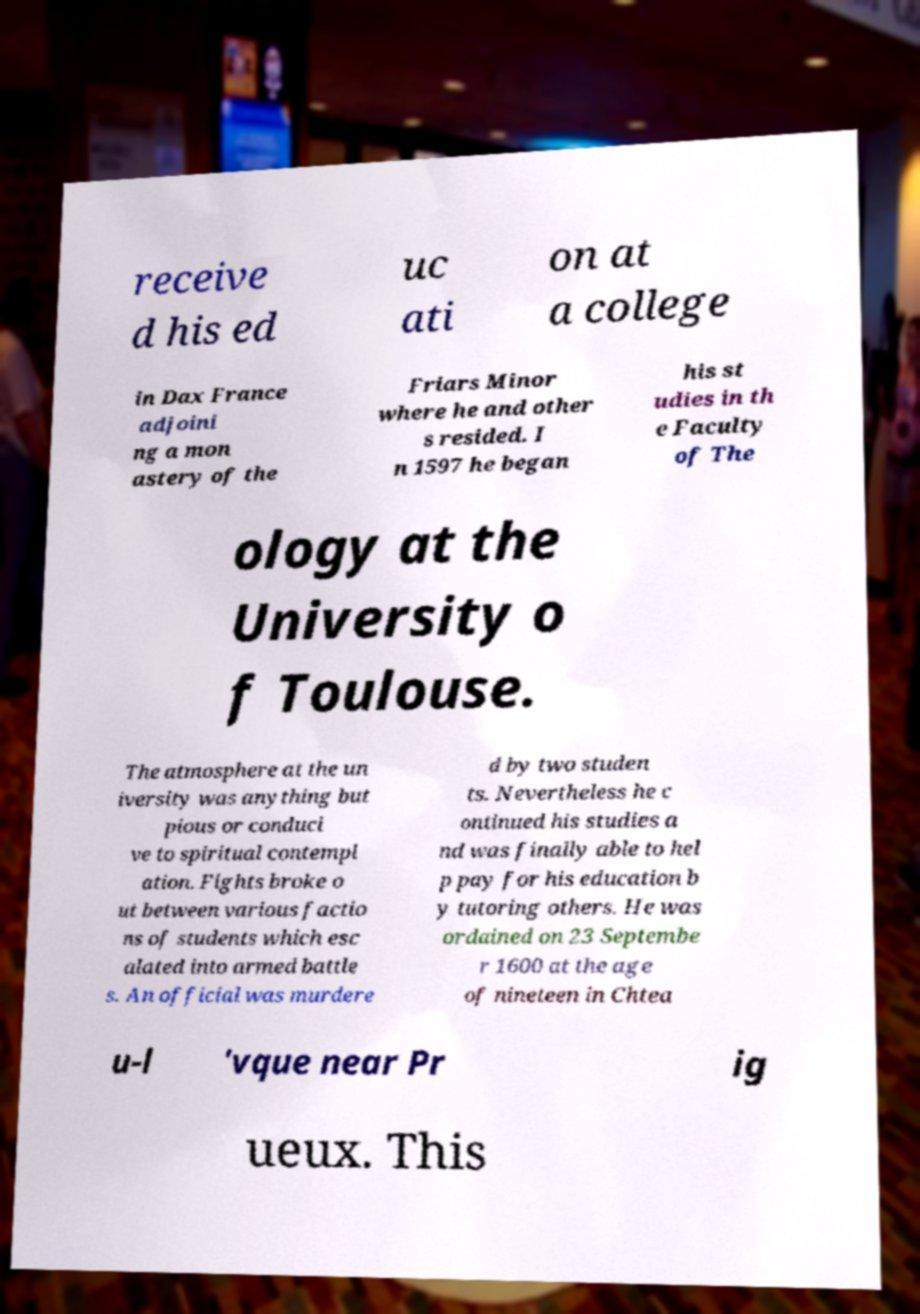Can you read and provide the text displayed in the image?This photo seems to have some interesting text. Can you extract and type it out for me? receive d his ed uc ati on at a college in Dax France adjoini ng a mon astery of the Friars Minor where he and other s resided. I n 1597 he began his st udies in th e Faculty of The ology at the University o f Toulouse. The atmosphere at the un iversity was anything but pious or conduci ve to spiritual contempl ation. Fights broke o ut between various factio ns of students which esc alated into armed battle s. An official was murdere d by two studen ts. Nevertheless he c ontinued his studies a nd was finally able to hel p pay for his education b y tutoring others. He was ordained on 23 Septembe r 1600 at the age of nineteen in Chtea u-l 'vque near Pr ig ueux. This 